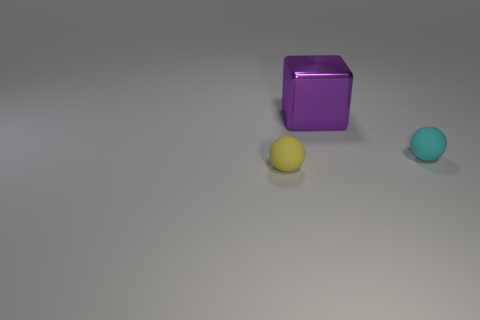How many small yellow things have the same shape as the cyan rubber object?
Make the answer very short. 1. Do the tiny cyan thing and the purple object to the right of the yellow ball have the same shape?
Ensure brevity in your answer.  No. There is a tiny yellow matte ball; how many big metallic objects are to the right of it?
Your answer should be very brief. 1. Are there any purple blocks of the same size as the yellow rubber sphere?
Your response must be concise. No. There is a small thing that is on the right side of the purple metallic thing; is it the same shape as the tiny yellow object?
Your answer should be compact. Yes. The big metallic cube has what color?
Offer a very short reply. Purple. Is there a cyan object?
Provide a short and direct response. Yes. The yellow ball that is the same material as the cyan sphere is what size?
Keep it short and to the point. Small. What is the shape of the large purple object to the right of the tiny matte sphere to the left of the tiny cyan matte object right of the purple metal cube?
Your response must be concise. Cube. Are there the same number of purple blocks right of the cyan ball and cyan blocks?
Your answer should be very brief. Yes. 